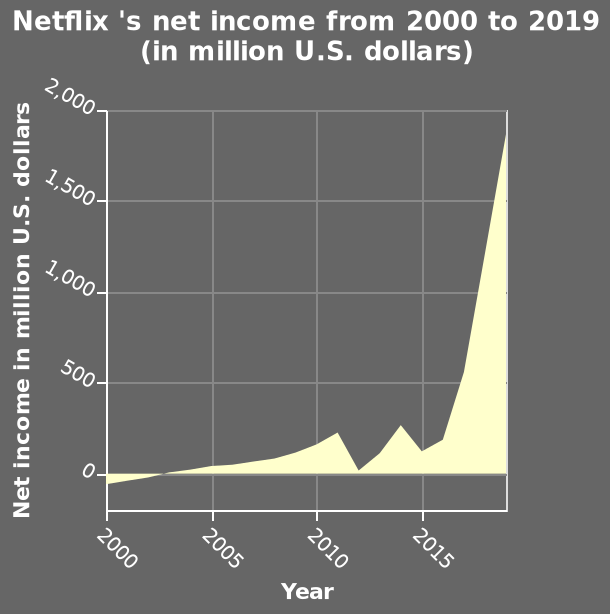<image>
From what year to what year does the area diagram depict Netflix's net income? The area diagram depicts Netflix's net income from the year 2000 to 2015. What was the trend of Netflix income from 2000-2020?  The trend of Netflix income from 2000-2020 shows exponential growth. please summary the statistics and relations of the chart Netflix income over the period 2000-2020 shows a trend of exponential growth. However income fell during 2012 and 2015. Describe the following image in detail Netflix 's net income from 2000 to 2019 (in million U.S. dollars) is a area diagram. On the y-axis, Net income in million U.S. dollars is plotted. Along the x-axis, Year is shown on a linear scale from 2000 to 2015. What type of diagram represents Netflix's net income? The net income of Netflix is represented by an area diagram. 